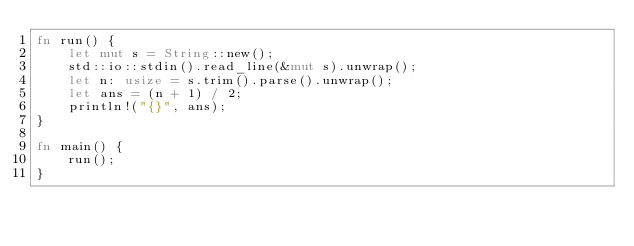Convert code to text. <code><loc_0><loc_0><loc_500><loc_500><_Rust_>fn run() {
    let mut s = String::new();
    std::io::stdin().read_line(&mut s).unwrap();
    let n: usize = s.trim().parse().unwrap();
    let ans = (n + 1) / 2;
    println!("{}", ans);
}

fn main() {
    run();
}</code> 